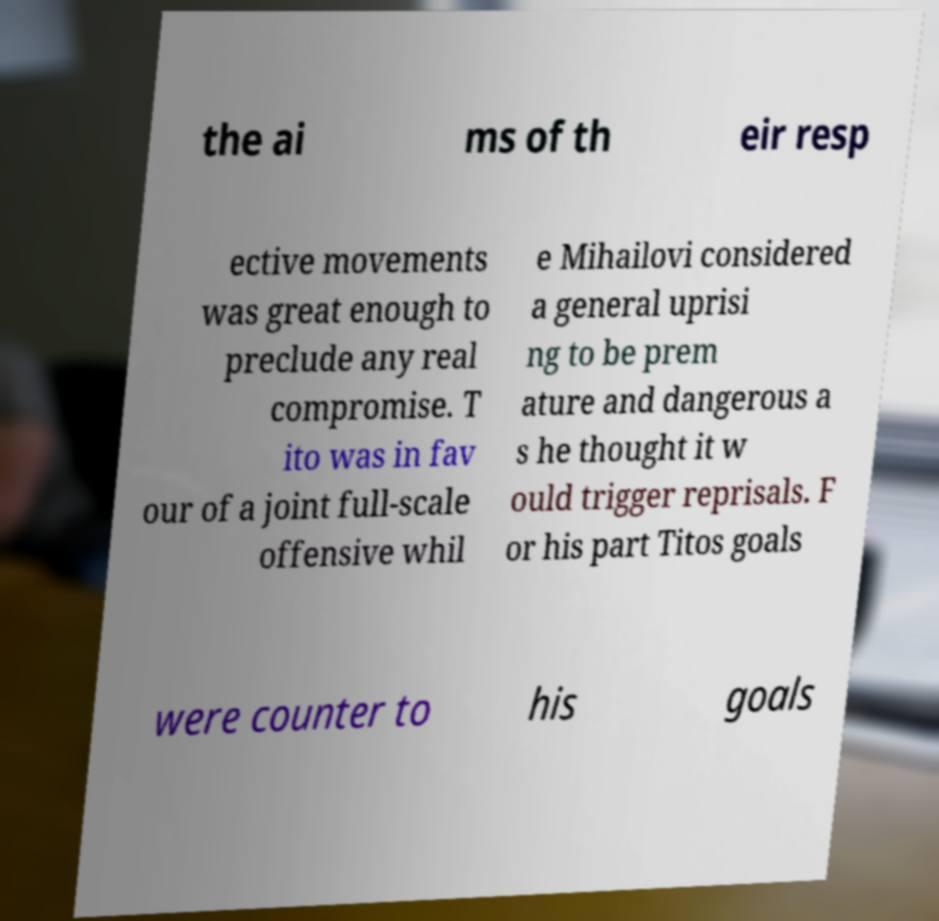Can you read and provide the text displayed in the image?This photo seems to have some interesting text. Can you extract and type it out for me? the ai ms of th eir resp ective movements was great enough to preclude any real compromise. T ito was in fav our of a joint full-scale offensive whil e Mihailovi considered a general uprisi ng to be prem ature and dangerous a s he thought it w ould trigger reprisals. F or his part Titos goals were counter to his goals 